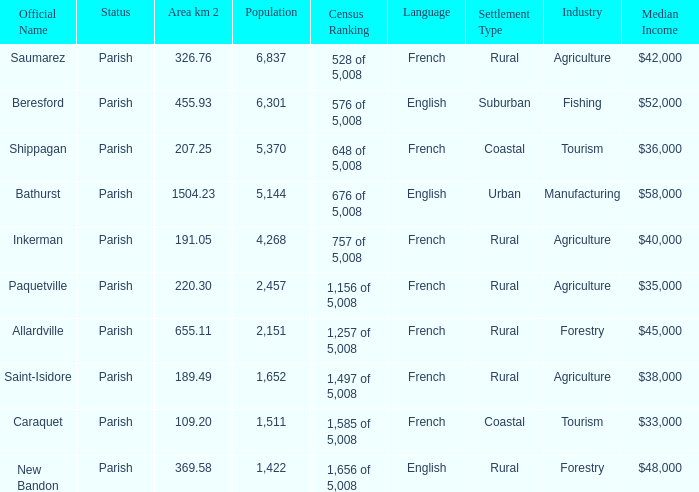What is the Area of the Saint-Isidore Parish with a Population smaller than 4,268? 189.49. 